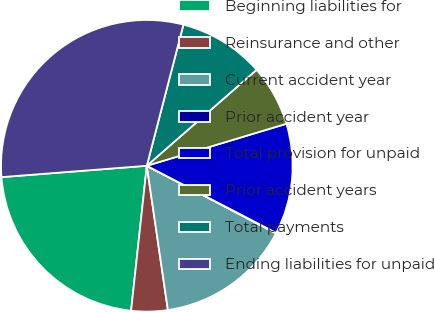Convert chart to OTSL. <chart><loc_0><loc_0><loc_500><loc_500><pie_chart><fcel>Beginning liabilities for<fcel>Reinsurance and other<fcel>Current accident year<fcel>Prior accident year<fcel>Total provision for unpaid<fcel>Prior accident years<fcel>Total payments<fcel>Ending liabilities for unpaid<nl><fcel>22.04%<fcel>4.03%<fcel>15.02%<fcel>0.05%<fcel>12.27%<fcel>6.78%<fcel>9.53%<fcel>30.28%<nl></chart> 